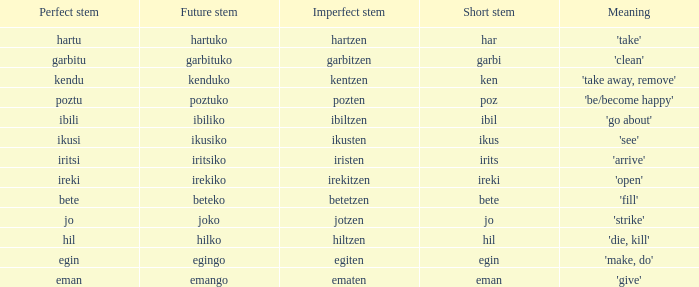What is the numeral for future stem for poztu? 1.0. 